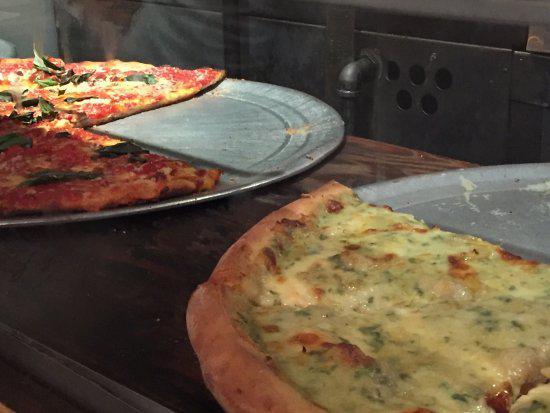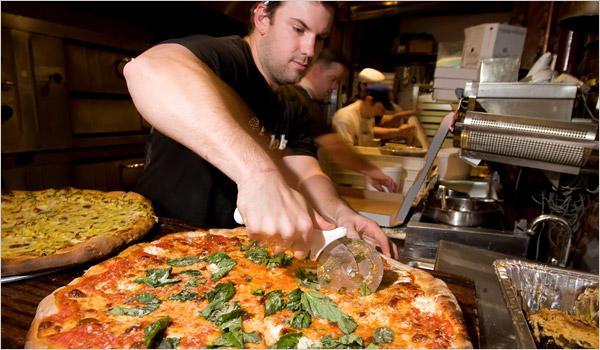The first image is the image on the left, the second image is the image on the right. Examine the images to the left and right. Is the description "In at least one of the images, there's a single pizza on a metal pan." accurate? Answer yes or no. No. The first image is the image on the left, the second image is the image on the right. Evaluate the accuracy of this statement regarding the images: "A person is holding a round-bladed cutting tool over a round pizza in the right image.". Is it true? Answer yes or no. Yes. 